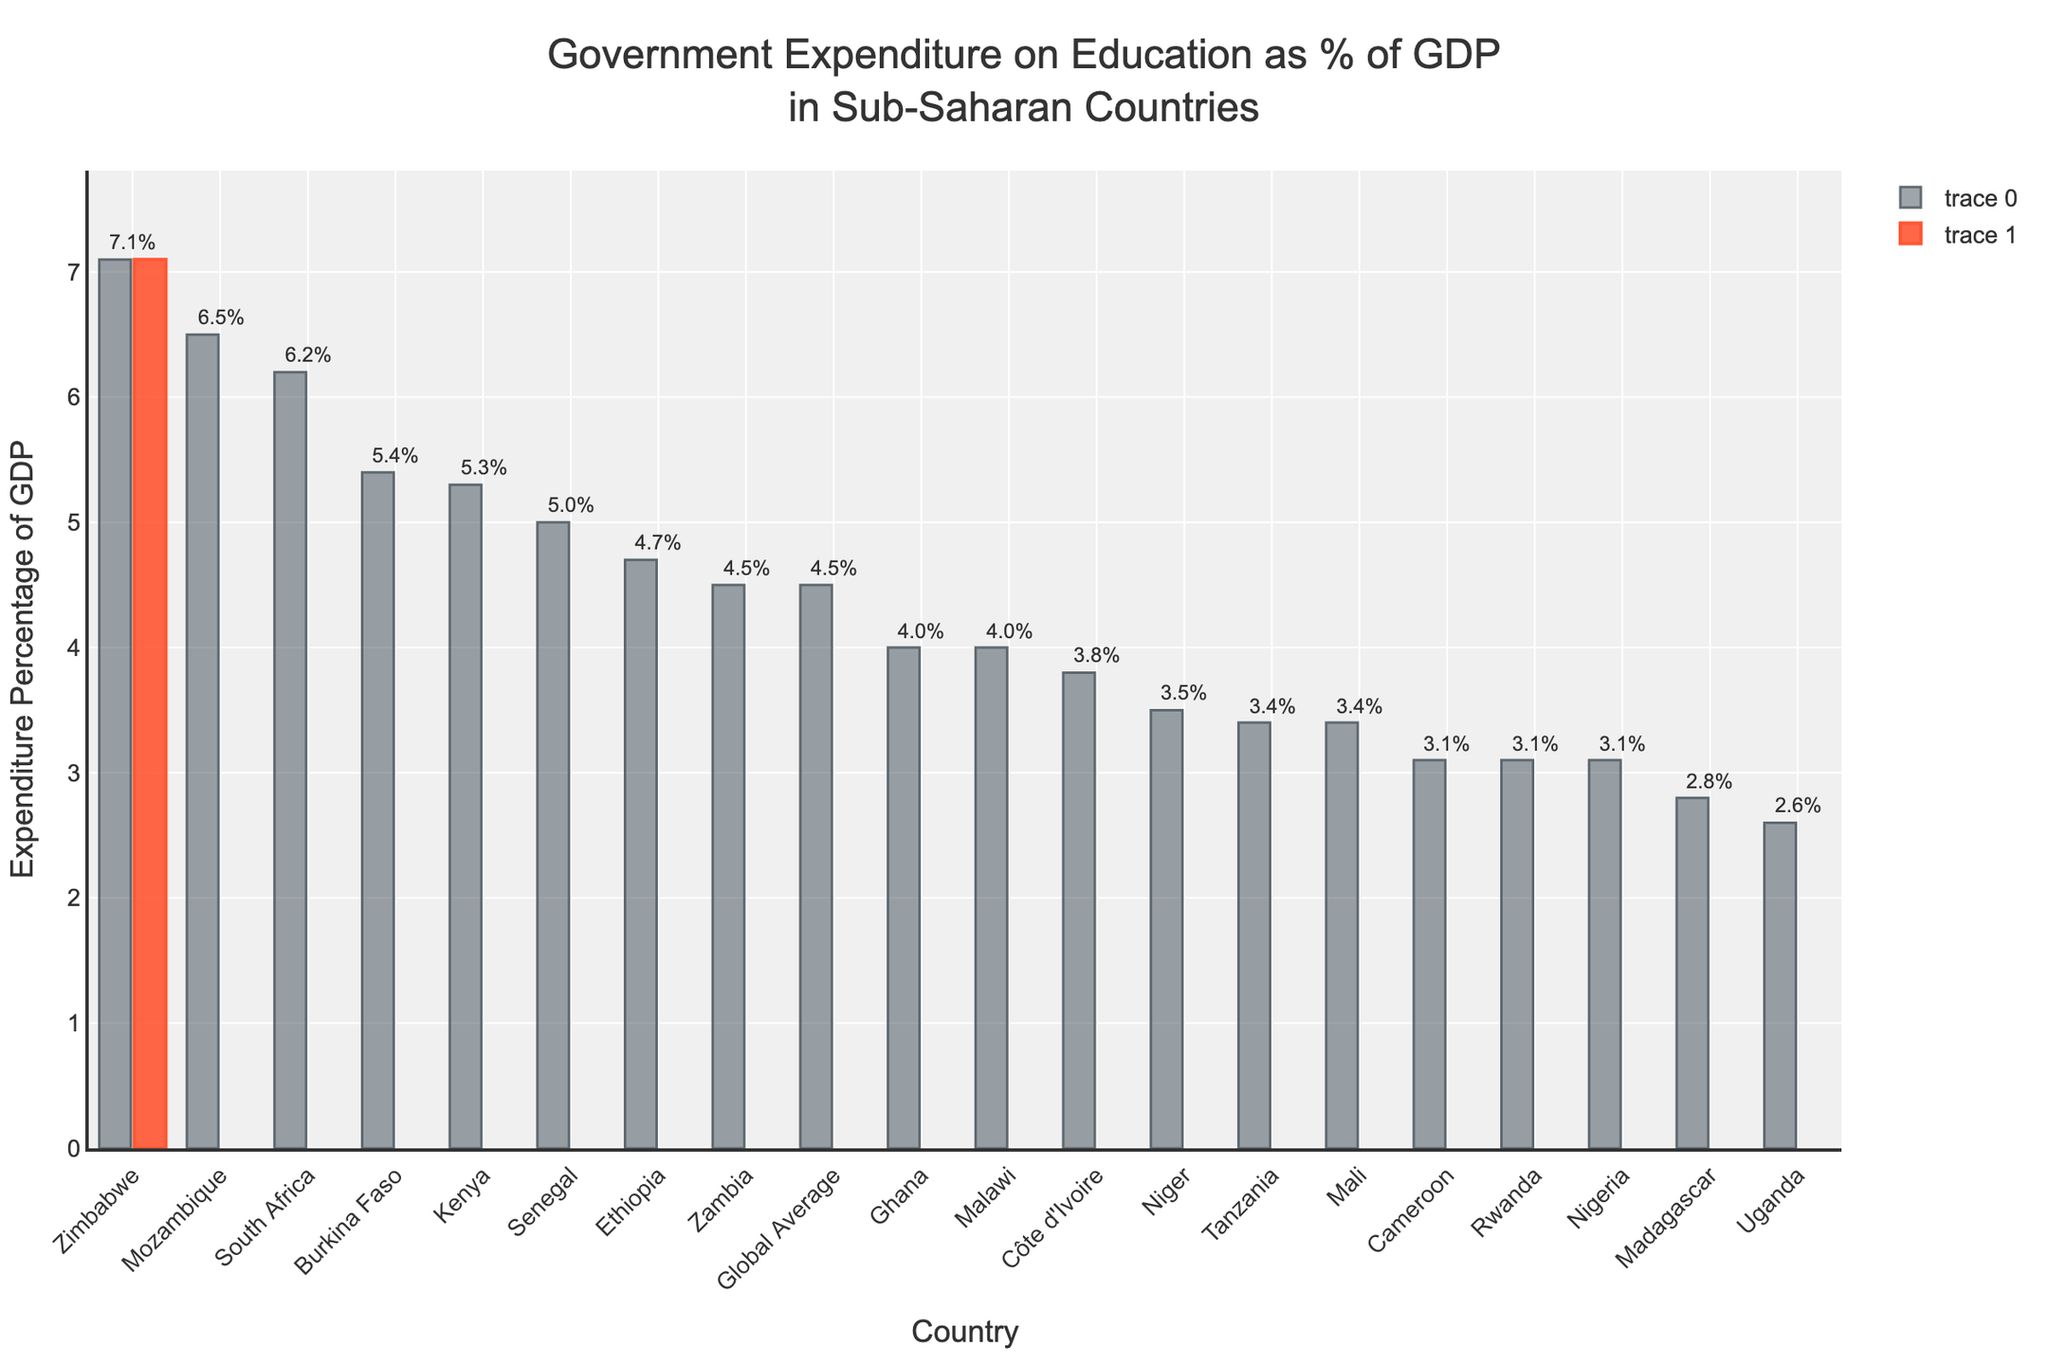Which country has the highest government expenditure on education as a percentage of GDP? By examining the height of the bars in the chart, Zimbabwe has the highest bar, indicating it has the highest expenditure rate.
Answer: Zimbabwe Which country has the lowest government expenditure on education as a percentage of GDP in Sub-Saharan Africa? The shortest bar among the Sub-Saharan countries in the chart is for Uganda, indicating it has the lowest expenditure rate.
Answer: Uganda How does the government expenditure on education in South Africa compare to the global average? South Africa's bar is higher than the global average bar, indicating South Africa's expenditure rate is higher than the global average.
Answer: Higher What is the difference in government expenditure on education between Kenya and Nigeria? The expenditure rates for Kenya and Nigeria are 5.3% and 3.1% respectively. Subtracting Nigeria's rate from Kenya's rate gives 5.3% - 3.1% = 2.2%.
Answer: 2.2% Which countries have an education expenditure percentage greater than the global average? By comparing the heights of the bars to the global average bar, the countries that are higher, thus having a greater expenditure percentage are South Africa, Kenya, Mozambique, Senegal, Burkina Faso, and Zimbabwe.
Answer: South Africa, Kenya, Mozambique, Senegal, Burkina Faso, Zimbabwe What's the average expenditure percentage on education for Ethiopia, Tanzania, Malawi, and Zambia? Sum the expenditure percentages: 4.7% (Ethiopia) + 3.4% (Tanzania) + 4.0% (Malawi) + 4.5% (Zambia) = 16.6%. Divide by 4 (number of countries) to get the average: 16.6% / 4 = 4.15%.
Answer: 4.15% How many countries have an expenditure rate that is less than 4%? Burkina Faso, Ghana, Tanzania, Uganda, and Madagascar are five countries that have bars indicating an expenditure rate less than 4%.
Answer: 5 Which countries have roughly equal government expenditure on education, around 3.1%? The countries with bars around the 3.1% mark are Nigeria, Cameroon, and Rwanda.
Answer: Nigeria, Cameroon, Rwanda Is Côte d'Ivoire's government expenditure on education higher or lower than the global average? Comparing Côte d'Ivoire's bar to the global average bar, it is seen that Côte d'Ivoire's bar is lower.
Answer: Lower 